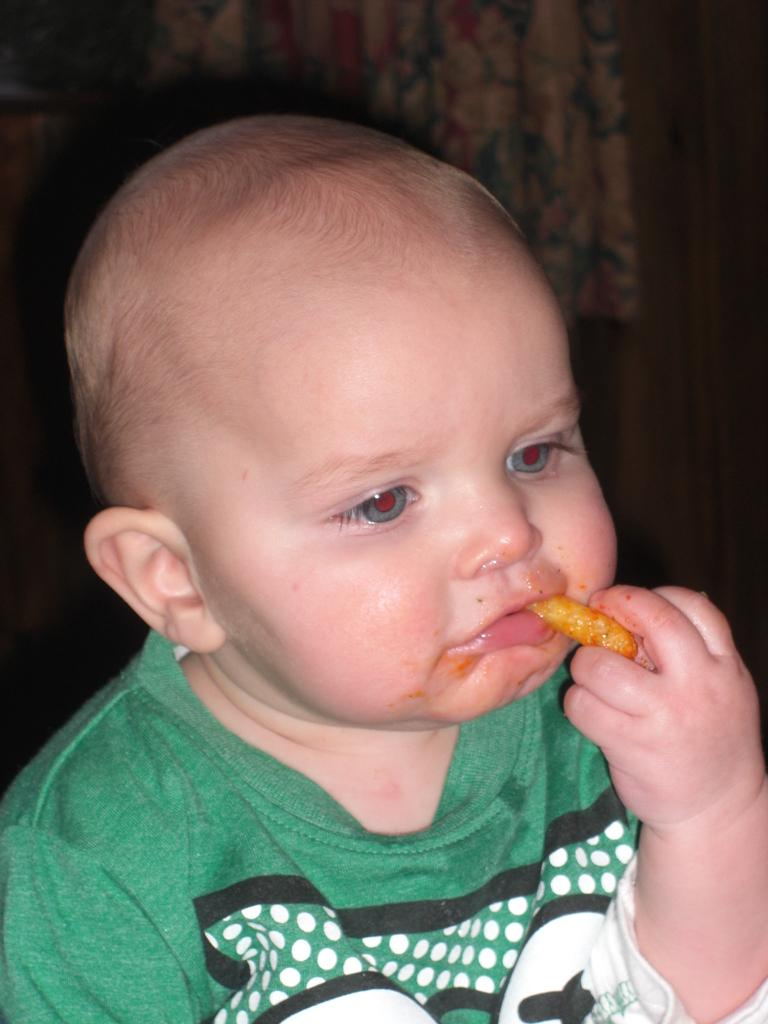What is the main subject of the image? The main subject of the image is a kid. What is the kid wearing? The kid is wearing a green dress. What is the kid holding in his hand? The kid is holding an edible item in his hand. What is the kid doing with the edible item? The kid is eating the edible item. Can you see any clouds in the image? There is no mention of clouds in the provided facts, and therefore we cannot determine if clouds are present in the image. 